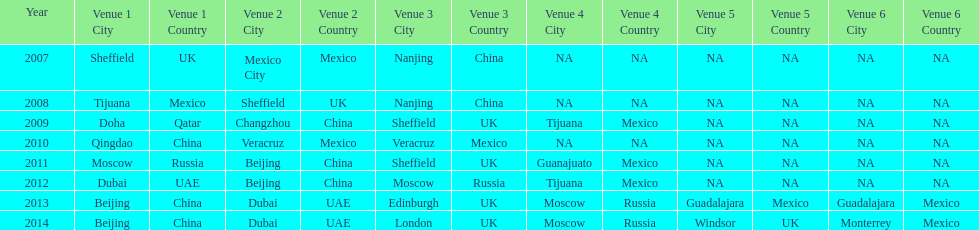Which is the only year that mexico is on a venue 2007. Write the full table. {'header': ['Year', 'Venue 1 City', 'Venue 1 Country', 'Venue 2 City', 'Venue 2 Country', 'Venue 3 City', 'Venue 3 Country', 'Venue 4 City', 'Venue 4 Country', 'Venue 5 City', 'Venue 5 Country', 'Venue 6 City', 'Venue 6 Country'], 'rows': [['2007', 'Sheffield', 'UK', 'Mexico City', 'Mexico', 'Nanjing', 'China', 'NA', 'NA', 'NA', 'NA', 'NA', 'NA'], ['2008', 'Tijuana', 'Mexico', 'Sheffield', 'UK', 'Nanjing', 'China', 'NA', 'NA', 'NA', 'NA', 'NA', 'NA'], ['2009', 'Doha', 'Qatar', 'Changzhou', 'China', 'Sheffield', 'UK', 'Tijuana', 'Mexico', 'NA', 'NA', 'NA', 'NA'], ['2010', 'Qingdao', 'China', 'Veracruz', 'Mexico', 'Veracruz', 'Mexico', 'NA', 'NA', 'NA', 'NA', 'NA', 'NA'], ['2011', 'Moscow', 'Russia', 'Beijing', 'China', 'Sheffield', 'UK', 'Guanajuato', 'Mexico', 'NA', 'NA', 'NA', 'NA'], ['2012', 'Dubai', 'UAE', 'Beijing', 'China', 'Moscow', 'Russia', 'Tijuana', 'Mexico', 'NA', 'NA', 'NA', 'NA'], ['2013', 'Beijing', 'China', 'Dubai', 'UAE', 'Edinburgh', 'UK', 'Moscow', 'Russia', 'Guadalajara', 'Mexico', 'Guadalajara', 'Mexico'], ['2014', 'Beijing', 'China', 'Dubai', 'UAE', 'London', 'UK', 'Moscow', 'Russia', 'Windsor', 'UK', 'Monterrey', 'Mexico']]} 